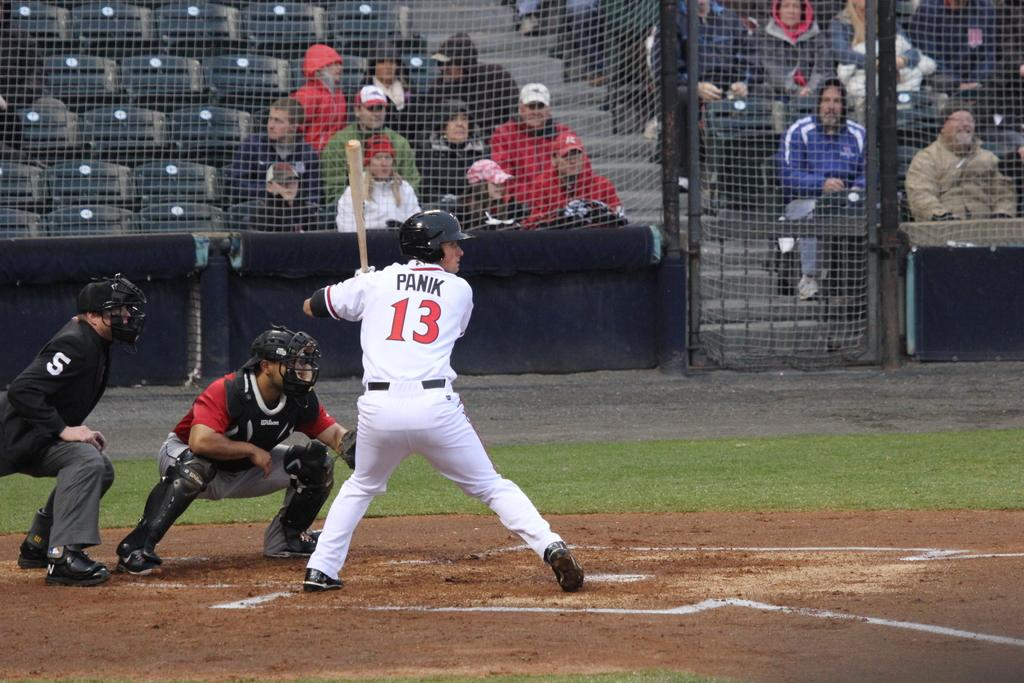<image>
Offer a succinct explanation of the picture presented. a player that has the number 13 on their jersey 